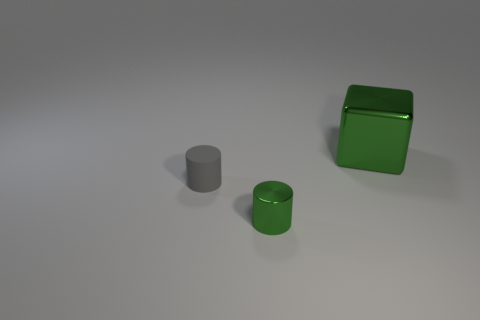Add 1 small metal cylinders. How many objects exist? 4 Subtract all cylinders. How many objects are left? 1 Subtract all green cubes. Subtract all small green metal objects. How many objects are left? 1 Add 1 gray objects. How many gray objects are left? 2 Add 2 small green cylinders. How many small green cylinders exist? 3 Subtract 0 cyan balls. How many objects are left? 3 Subtract 1 blocks. How many blocks are left? 0 Subtract all yellow cubes. Subtract all purple balls. How many cubes are left? 1 Subtract all cyan blocks. How many gray cylinders are left? 1 